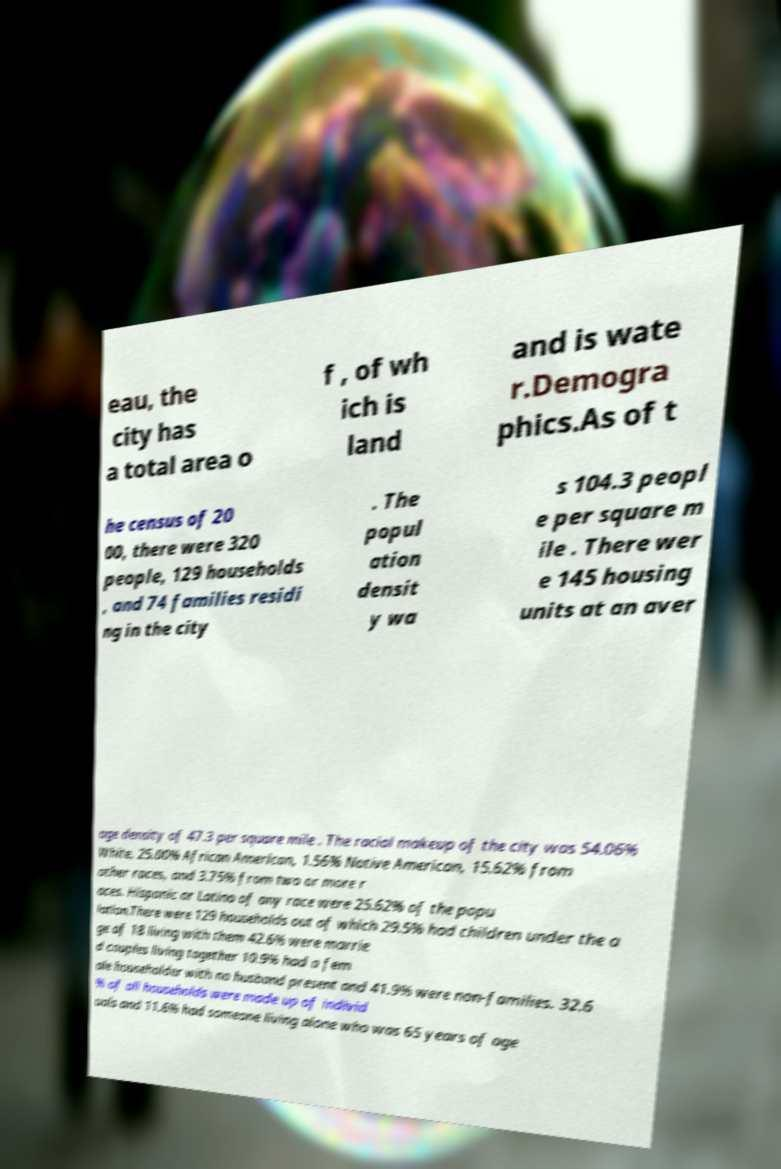What messages or text are displayed in this image? I need them in a readable, typed format. eau, the city has a total area o f , of wh ich is land and is wate r.Demogra phics.As of t he census of 20 00, there were 320 people, 129 households , and 74 families residi ng in the city . The popul ation densit y wa s 104.3 peopl e per square m ile . There wer e 145 housing units at an aver age density of 47.3 per square mile . The racial makeup of the city was 54.06% White, 25.00% African American, 1.56% Native American, 15.62% from other races, and 3.75% from two or more r aces. Hispanic or Latino of any race were 25.62% of the popu lation.There were 129 households out of which 29.5% had children under the a ge of 18 living with them 42.6% were marrie d couples living together 10.9% had a fem ale householder with no husband present and 41.9% were non-families. 32.6 % of all households were made up of individ uals and 11.6% had someone living alone who was 65 years of age 